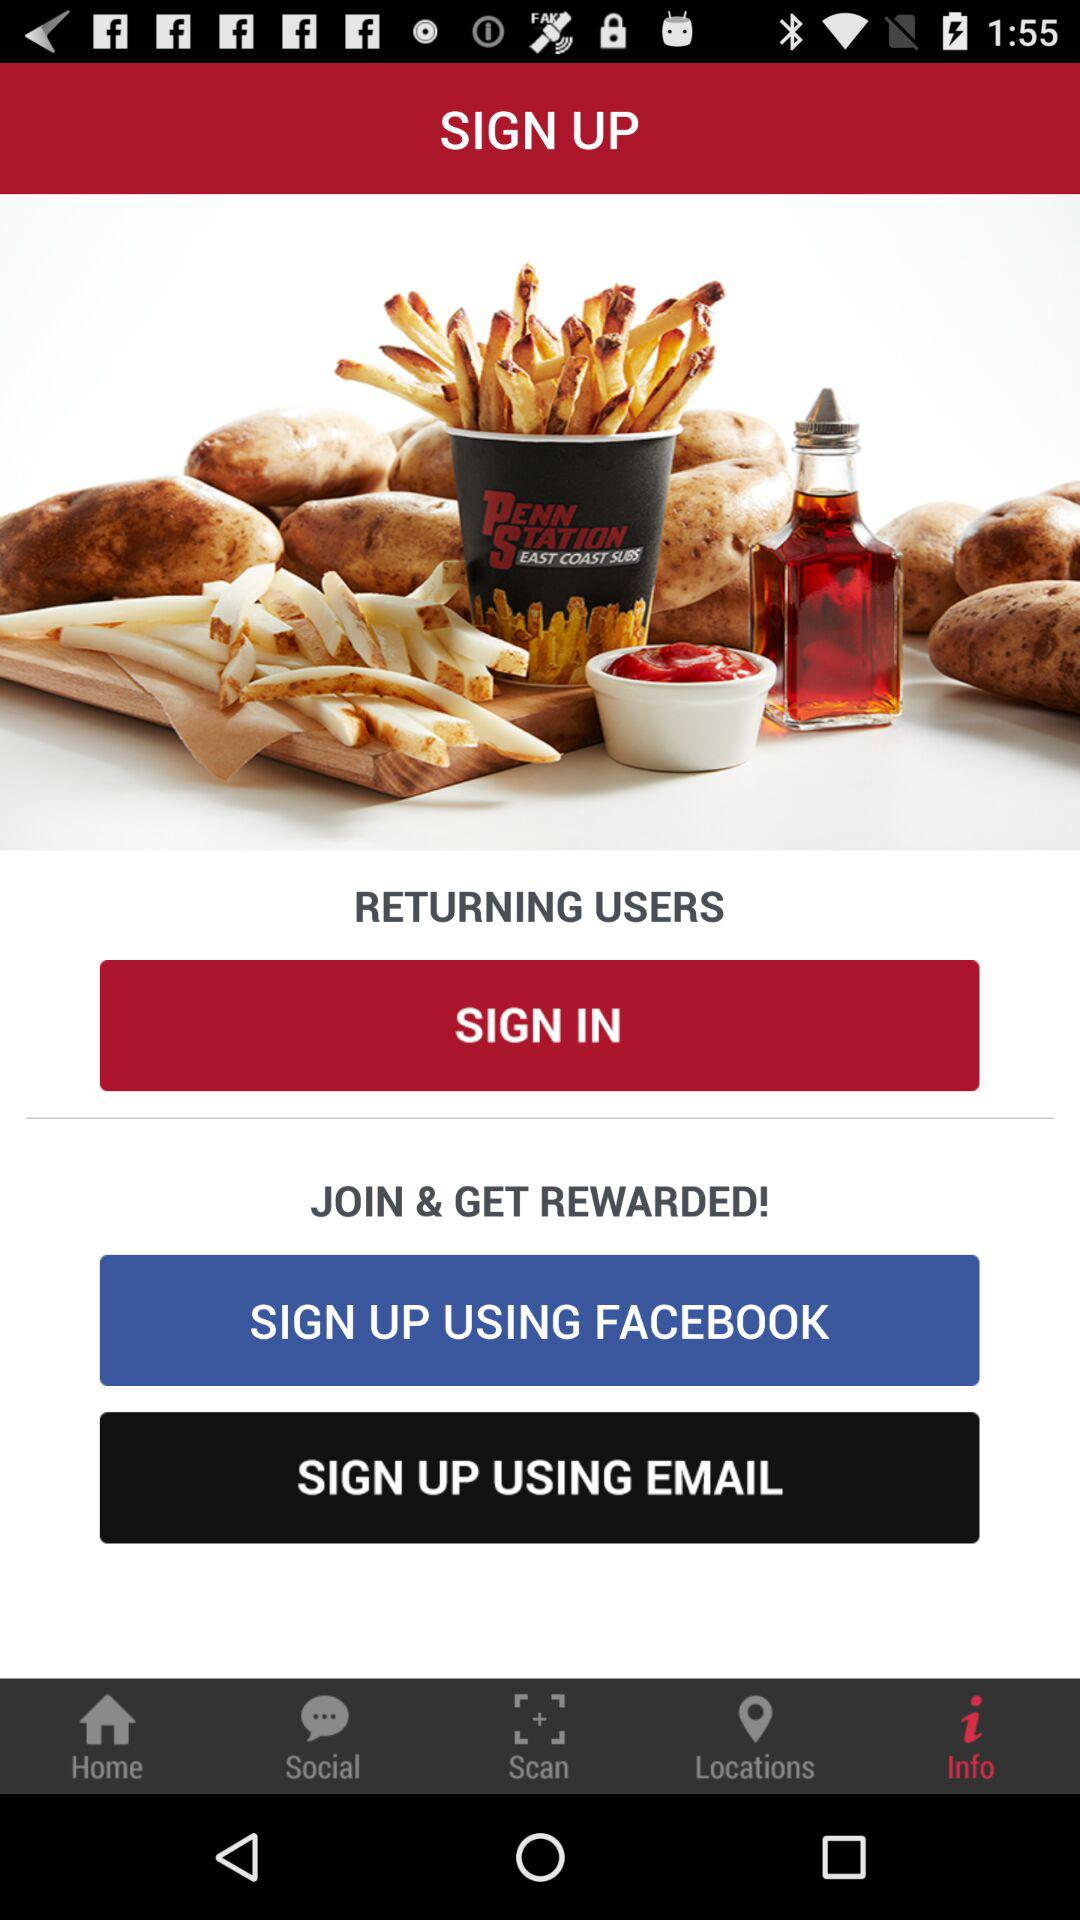Which tab is selected? The selected tab is "Info". 